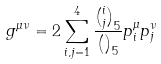Convert formula to latex. <formula><loc_0><loc_0><loc_500><loc_500>g ^ { \mu \nu } = 2 \sum ^ { 4 } _ { i , j = 1 } \frac { { i \choose j } _ { 5 } } { { \choose } _ { 5 } } p _ { i } ^ { \mu } p _ { j } ^ { \nu }</formula> 